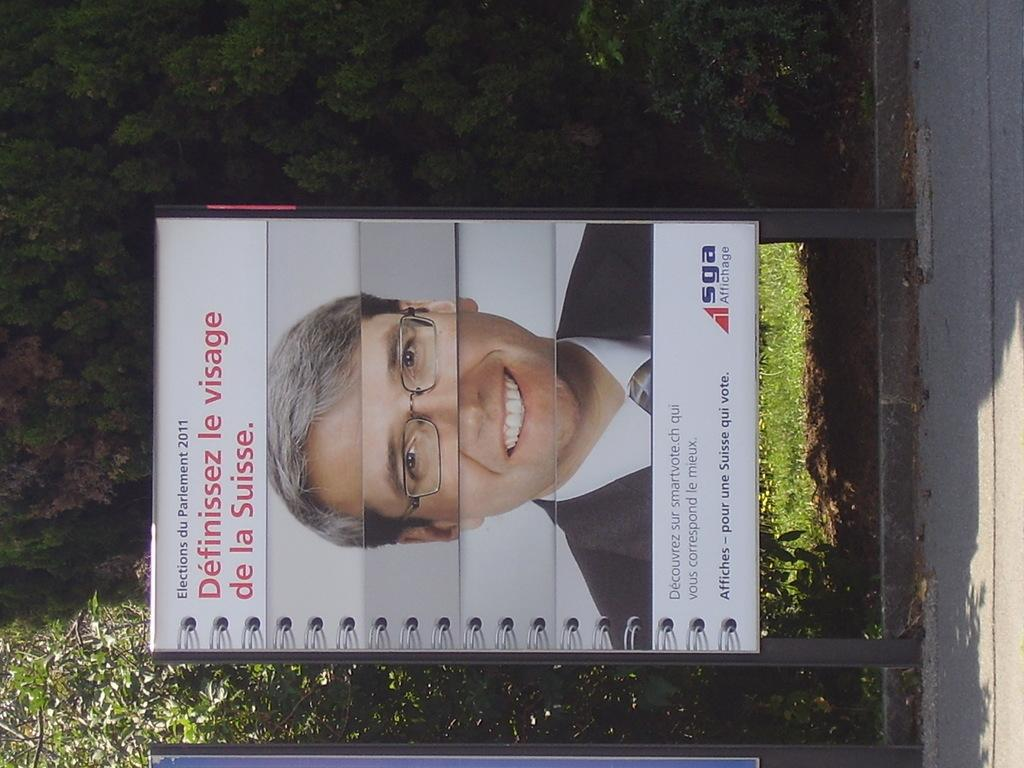What is the main subject of the image? There is a board with an image and text in the image. What can be seen in the background of the image? There are trees in the background of the image. What type of flame can be seen on the board in the image? There is no flame present on the board in the image. What is the opinion of the person who created the board in the image? The image does not provide any information about the opinion of the person who created the board. 